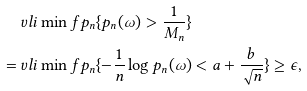Convert formula to latex. <formula><loc_0><loc_0><loc_500><loc_500>& \ v l i \min f p _ { n } \{ p _ { n } ( \omega ) > \frac { 1 } { M _ { n } } \} \\ = & \ v l i \min f p _ { n } \{ - \frac { 1 } { n } \log p _ { n } ( \omega ) < a + \frac { b } { \sqrt { n } } \} \geq \epsilon ,</formula> 